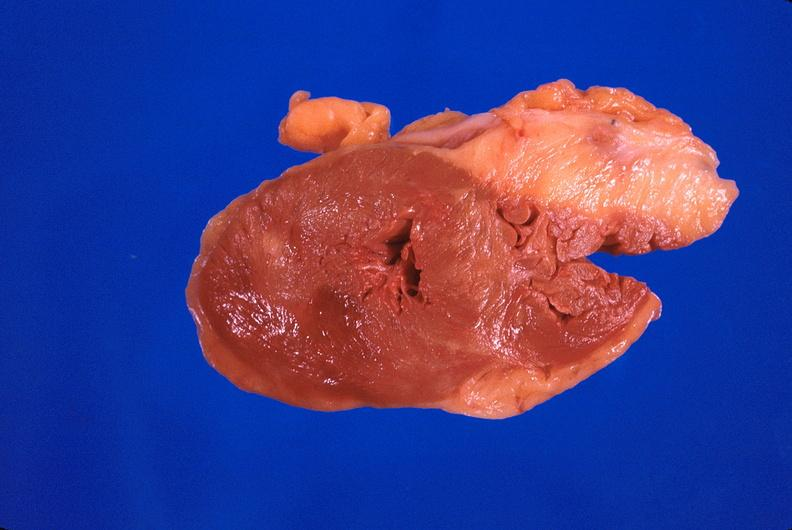does this image show heart, hypertrophy, chronic rheumatic heart disease with prosthetic mitral valve?
Answer the question using a single word or phrase. Yes 